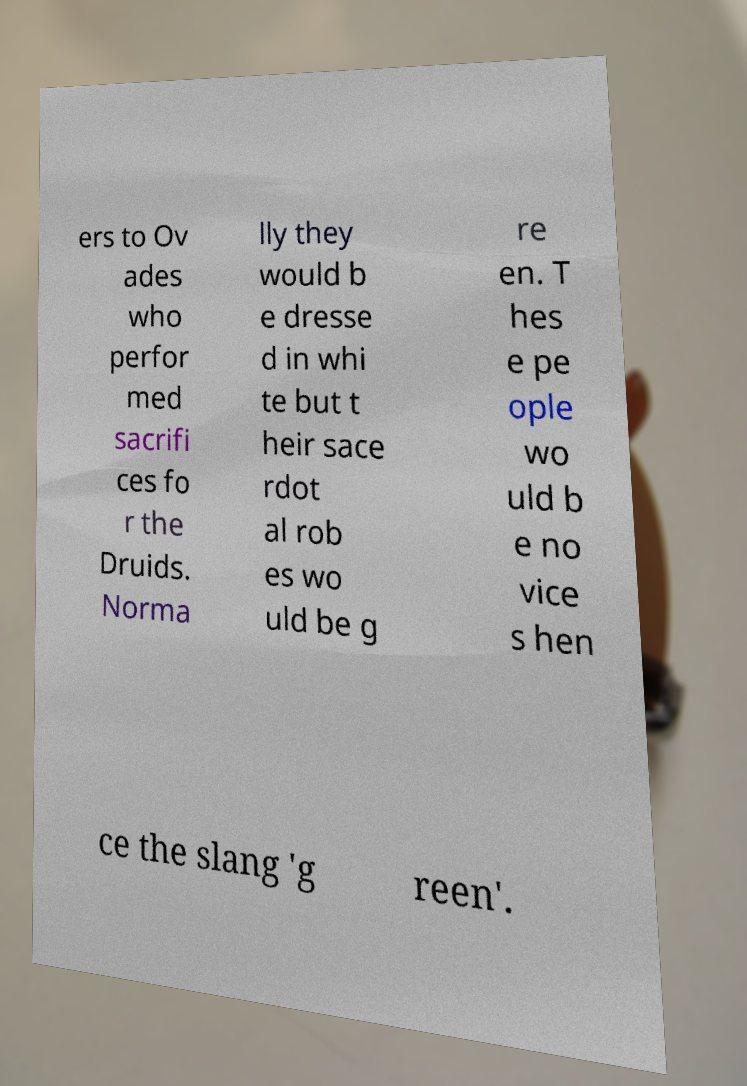Please read and relay the text visible in this image. What does it say? ers to Ov ades who perfor med sacrifi ces fo r the Druids. Norma lly they would b e dresse d in whi te but t heir sace rdot al rob es wo uld be g re en. T hes e pe ople wo uld b e no vice s hen ce the slang 'g reen'. 